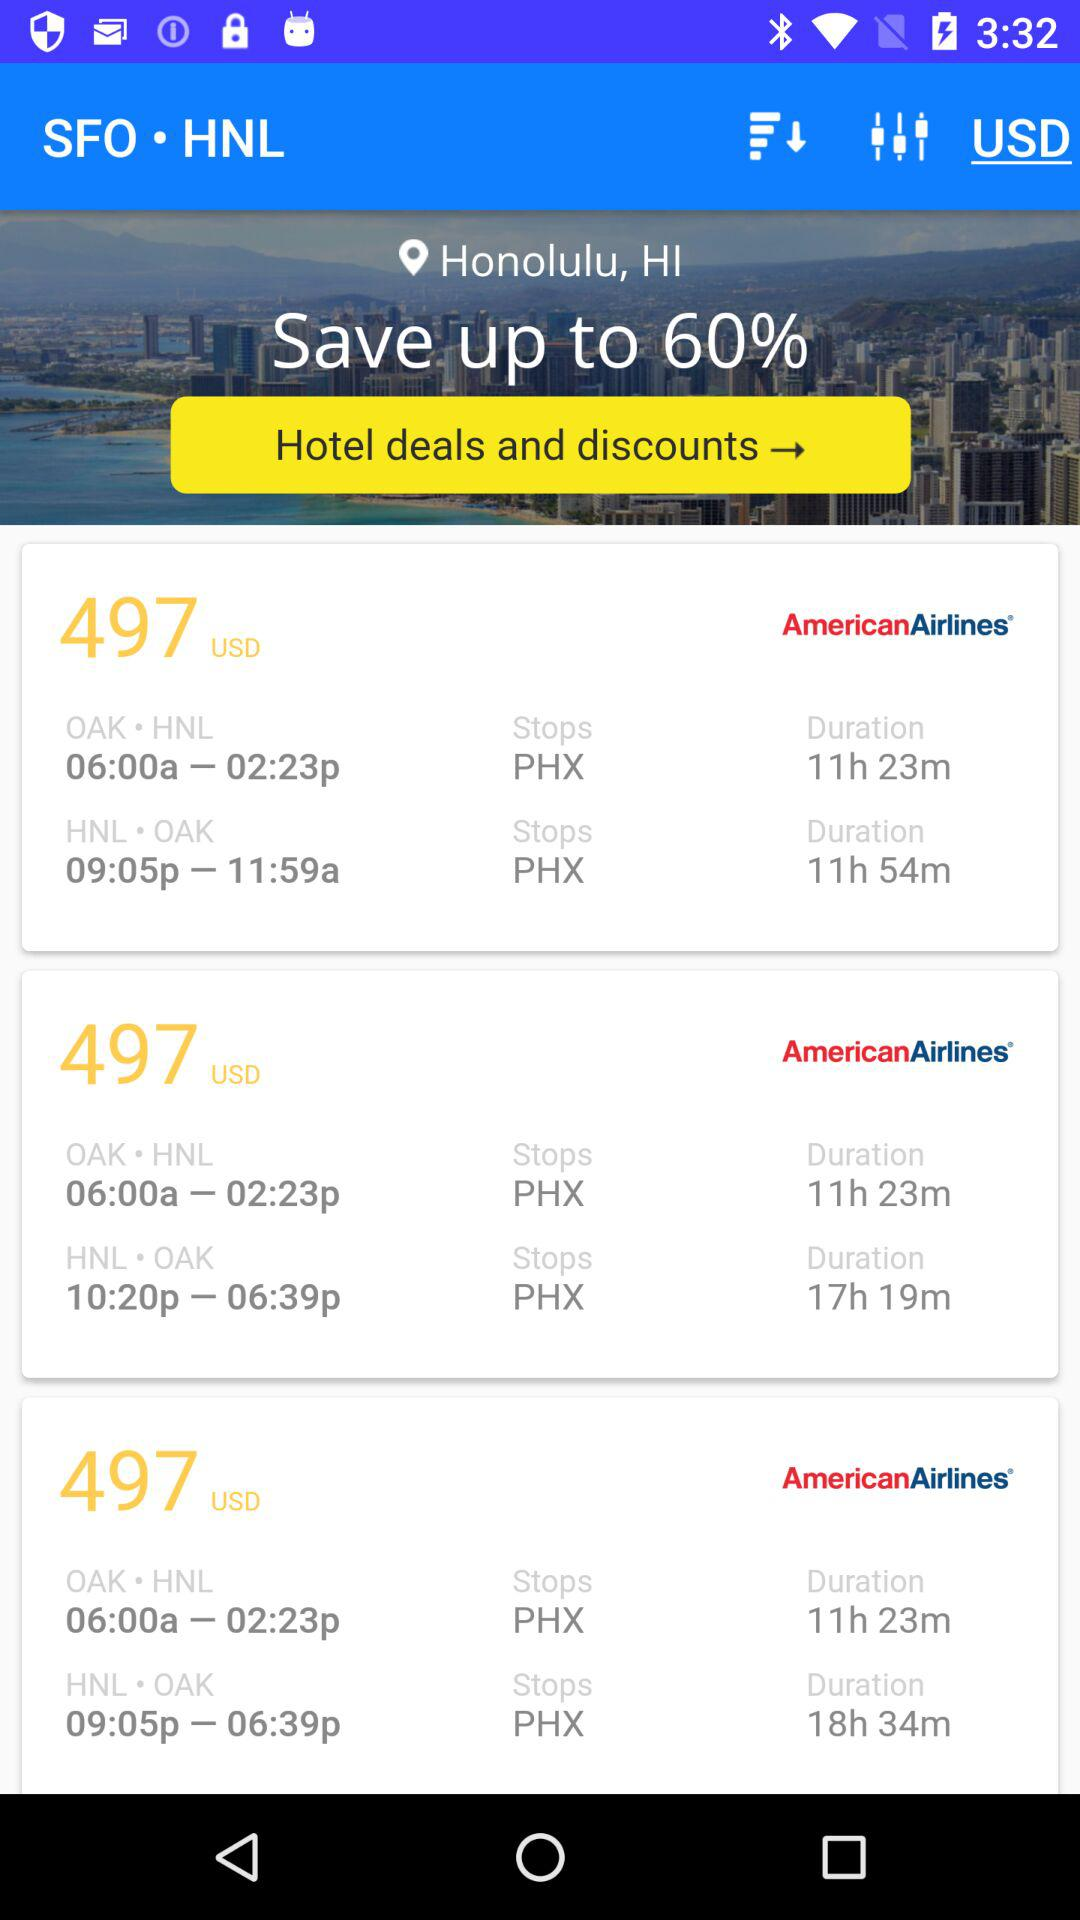What's the flight duration from OAK to HNL? The flight duration from OAK to HNL is 11 hours 23 minutes. 